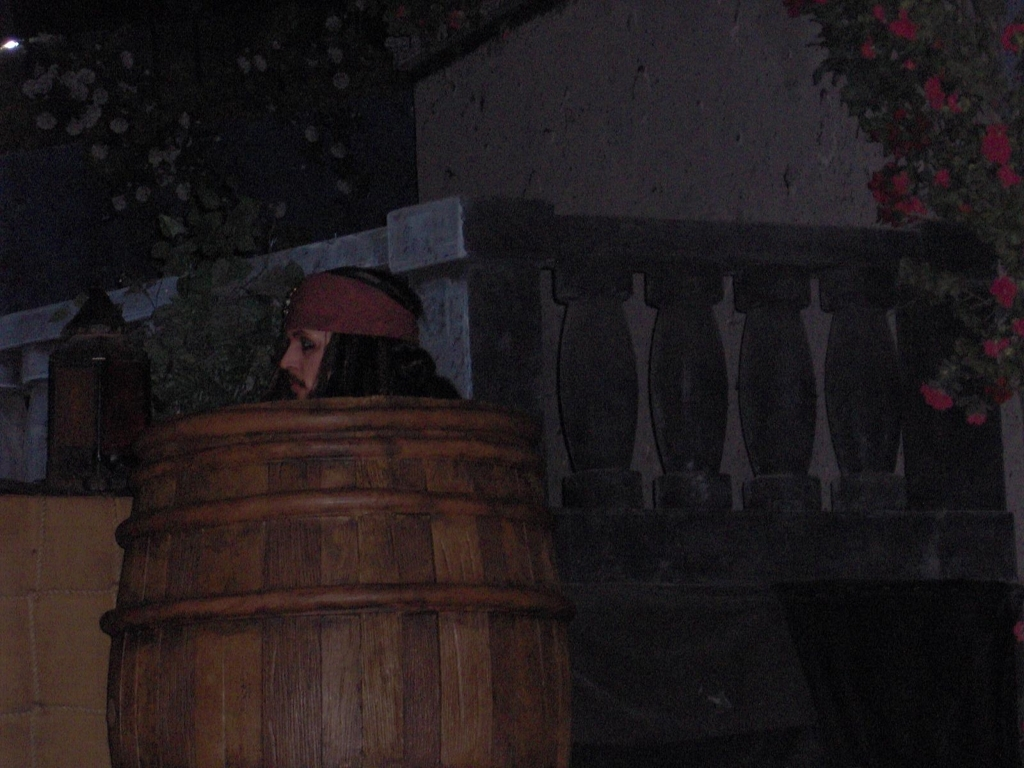Does the image successfully create a good atmosphere? The image projects a mysterious and somewhat foreboding atmosphere, with a person peeking out from behind what appears to be a large wooden barrel. The dim lighting and the presence of foliage and flowers in the background contribute to a feeling of secrecy and potentially an aspect of concealment or intrigue. 